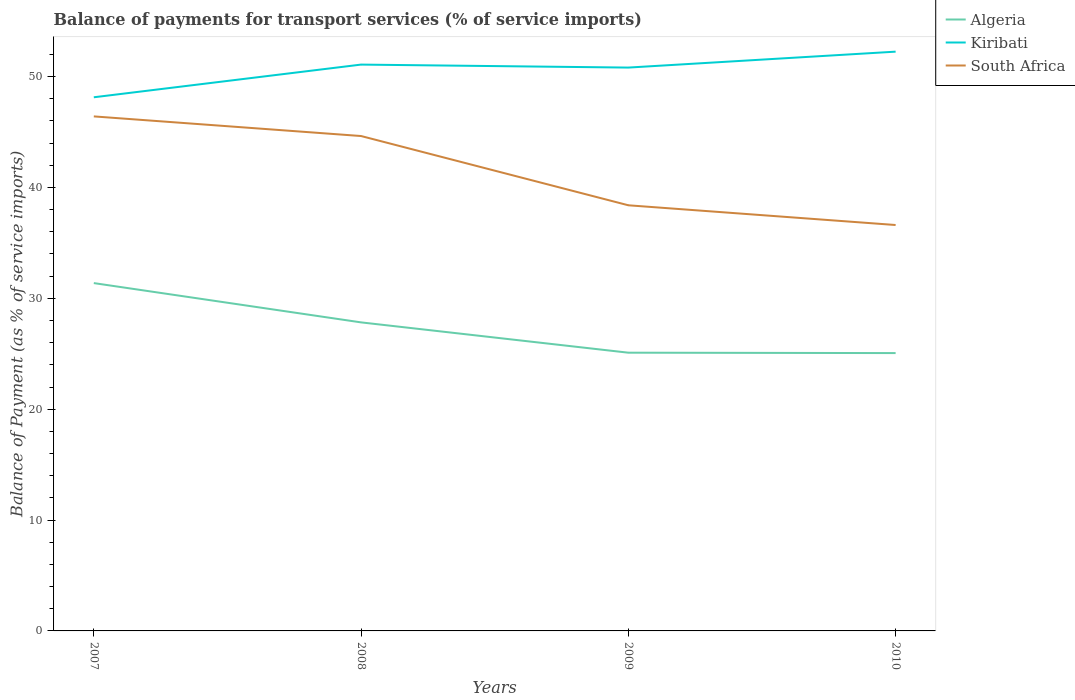Is the number of lines equal to the number of legend labels?
Provide a succinct answer. Yes. Across all years, what is the maximum balance of payments for transport services in Kiribati?
Offer a terse response. 48.13. What is the total balance of payments for transport services in Kiribati in the graph?
Make the answer very short. -2.95. What is the difference between the highest and the second highest balance of payments for transport services in Algeria?
Give a very brief answer. 6.31. Is the balance of payments for transport services in South Africa strictly greater than the balance of payments for transport services in Kiribati over the years?
Your answer should be compact. Yes. How many lines are there?
Your answer should be very brief. 3. How many years are there in the graph?
Make the answer very short. 4. Where does the legend appear in the graph?
Your response must be concise. Top right. What is the title of the graph?
Give a very brief answer. Balance of payments for transport services (% of service imports). What is the label or title of the X-axis?
Ensure brevity in your answer.  Years. What is the label or title of the Y-axis?
Provide a short and direct response. Balance of Payment (as % of service imports). What is the Balance of Payment (as % of service imports) of Algeria in 2007?
Your answer should be very brief. 31.37. What is the Balance of Payment (as % of service imports) of Kiribati in 2007?
Make the answer very short. 48.13. What is the Balance of Payment (as % of service imports) of South Africa in 2007?
Keep it short and to the point. 46.41. What is the Balance of Payment (as % of service imports) in Algeria in 2008?
Make the answer very short. 27.83. What is the Balance of Payment (as % of service imports) of Kiribati in 2008?
Keep it short and to the point. 51.08. What is the Balance of Payment (as % of service imports) in South Africa in 2008?
Give a very brief answer. 44.64. What is the Balance of Payment (as % of service imports) of Algeria in 2009?
Offer a very short reply. 25.1. What is the Balance of Payment (as % of service imports) in Kiribati in 2009?
Make the answer very short. 50.81. What is the Balance of Payment (as % of service imports) in South Africa in 2009?
Provide a succinct answer. 38.39. What is the Balance of Payment (as % of service imports) of Algeria in 2010?
Give a very brief answer. 25.06. What is the Balance of Payment (as % of service imports) in Kiribati in 2010?
Ensure brevity in your answer.  52.25. What is the Balance of Payment (as % of service imports) of South Africa in 2010?
Ensure brevity in your answer.  36.61. Across all years, what is the maximum Balance of Payment (as % of service imports) in Algeria?
Give a very brief answer. 31.37. Across all years, what is the maximum Balance of Payment (as % of service imports) in Kiribati?
Keep it short and to the point. 52.25. Across all years, what is the maximum Balance of Payment (as % of service imports) in South Africa?
Provide a succinct answer. 46.41. Across all years, what is the minimum Balance of Payment (as % of service imports) of Algeria?
Make the answer very short. 25.06. Across all years, what is the minimum Balance of Payment (as % of service imports) in Kiribati?
Your answer should be very brief. 48.13. Across all years, what is the minimum Balance of Payment (as % of service imports) of South Africa?
Offer a terse response. 36.61. What is the total Balance of Payment (as % of service imports) in Algeria in the graph?
Your answer should be compact. 109.36. What is the total Balance of Payment (as % of service imports) of Kiribati in the graph?
Your answer should be compact. 202.28. What is the total Balance of Payment (as % of service imports) of South Africa in the graph?
Keep it short and to the point. 166.05. What is the difference between the Balance of Payment (as % of service imports) of Algeria in 2007 and that in 2008?
Your response must be concise. 3.54. What is the difference between the Balance of Payment (as % of service imports) of Kiribati in 2007 and that in 2008?
Provide a succinct answer. -2.95. What is the difference between the Balance of Payment (as % of service imports) of South Africa in 2007 and that in 2008?
Provide a succinct answer. 1.77. What is the difference between the Balance of Payment (as % of service imports) of Algeria in 2007 and that in 2009?
Offer a very short reply. 6.28. What is the difference between the Balance of Payment (as % of service imports) in Kiribati in 2007 and that in 2009?
Keep it short and to the point. -2.68. What is the difference between the Balance of Payment (as % of service imports) of South Africa in 2007 and that in 2009?
Keep it short and to the point. 8.02. What is the difference between the Balance of Payment (as % of service imports) in Algeria in 2007 and that in 2010?
Ensure brevity in your answer.  6.31. What is the difference between the Balance of Payment (as % of service imports) in Kiribati in 2007 and that in 2010?
Ensure brevity in your answer.  -4.12. What is the difference between the Balance of Payment (as % of service imports) of South Africa in 2007 and that in 2010?
Offer a terse response. 9.8. What is the difference between the Balance of Payment (as % of service imports) of Algeria in 2008 and that in 2009?
Ensure brevity in your answer.  2.73. What is the difference between the Balance of Payment (as % of service imports) in Kiribati in 2008 and that in 2009?
Give a very brief answer. 0.27. What is the difference between the Balance of Payment (as % of service imports) in South Africa in 2008 and that in 2009?
Your answer should be very brief. 6.25. What is the difference between the Balance of Payment (as % of service imports) in Algeria in 2008 and that in 2010?
Your response must be concise. 2.77. What is the difference between the Balance of Payment (as % of service imports) of Kiribati in 2008 and that in 2010?
Your answer should be very brief. -1.17. What is the difference between the Balance of Payment (as % of service imports) in South Africa in 2008 and that in 2010?
Offer a very short reply. 8.03. What is the difference between the Balance of Payment (as % of service imports) in Algeria in 2009 and that in 2010?
Ensure brevity in your answer.  0.04. What is the difference between the Balance of Payment (as % of service imports) in Kiribati in 2009 and that in 2010?
Make the answer very short. -1.44. What is the difference between the Balance of Payment (as % of service imports) in South Africa in 2009 and that in 2010?
Your answer should be very brief. 1.78. What is the difference between the Balance of Payment (as % of service imports) in Algeria in 2007 and the Balance of Payment (as % of service imports) in Kiribati in 2008?
Offer a very short reply. -19.71. What is the difference between the Balance of Payment (as % of service imports) in Algeria in 2007 and the Balance of Payment (as % of service imports) in South Africa in 2008?
Provide a short and direct response. -13.26. What is the difference between the Balance of Payment (as % of service imports) of Kiribati in 2007 and the Balance of Payment (as % of service imports) of South Africa in 2008?
Your answer should be very brief. 3.5. What is the difference between the Balance of Payment (as % of service imports) of Algeria in 2007 and the Balance of Payment (as % of service imports) of Kiribati in 2009?
Offer a very short reply. -19.44. What is the difference between the Balance of Payment (as % of service imports) of Algeria in 2007 and the Balance of Payment (as % of service imports) of South Africa in 2009?
Your answer should be compact. -7.02. What is the difference between the Balance of Payment (as % of service imports) in Kiribati in 2007 and the Balance of Payment (as % of service imports) in South Africa in 2009?
Keep it short and to the point. 9.74. What is the difference between the Balance of Payment (as % of service imports) of Algeria in 2007 and the Balance of Payment (as % of service imports) of Kiribati in 2010?
Offer a terse response. -20.88. What is the difference between the Balance of Payment (as % of service imports) in Algeria in 2007 and the Balance of Payment (as % of service imports) in South Africa in 2010?
Provide a succinct answer. -5.24. What is the difference between the Balance of Payment (as % of service imports) in Kiribati in 2007 and the Balance of Payment (as % of service imports) in South Africa in 2010?
Keep it short and to the point. 11.52. What is the difference between the Balance of Payment (as % of service imports) of Algeria in 2008 and the Balance of Payment (as % of service imports) of Kiribati in 2009?
Your answer should be very brief. -22.98. What is the difference between the Balance of Payment (as % of service imports) of Algeria in 2008 and the Balance of Payment (as % of service imports) of South Africa in 2009?
Your answer should be very brief. -10.56. What is the difference between the Balance of Payment (as % of service imports) in Kiribati in 2008 and the Balance of Payment (as % of service imports) in South Africa in 2009?
Your answer should be compact. 12.69. What is the difference between the Balance of Payment (as % of service imports) of Algeria in 2008 and the Balance of Payment (as % of service imports) of Kiribati in 2010?
Your answer should be compact. -24.42. What is the difference between the Balance of Payment (as % of service imports) of Algeria in 2008 and the Balance of Payment (as % of service imports) of South Africa in 2010?
Your answer should be compact. -8.78. What is the difference between the Balance of Payment (as % of service imports) in Kiribati in 2008 and the Balance of Payment (as % of service imports) in South Africa in 2010?
Give a very brief answer. 14.47. What is the difference between the Balance of Payment (as % of service imports) of Algeria in 2009 and the Balance of Payment (as % of service imports) of Kiribati in 2010?
Provide a short and direct response. -27.15. What is the difference between the Balance of Payment (as % of service imports) in Algeria in 2009 and the Balance of Payment (as % of service imports) in South Africa in 2010?
Provide a succinct answer. -11.52. What is the difference between the Balance of Payment (as % of service imports) in Kiribati in 2009 and the Balance of Payment (as % of service imports) in South Africa in 2010?
Make the answer very short. 14.2. What is the average Balance of Payment (as % of service imports) in Algeria per year?
Give a very brief answer. 27.34. What is the average Balance of Payment (as % of service imports) of Kiribati per year?
Provide a succinct answer. 50.57. What is the average Balance of Payment (as % of service imports) of South Africa per year?
Provide a succinct answer. 41.51. In the year 2007, what is the difference between the Balance of Payment (as % of service imports) in Algeria and Balance of Payment (as % of service imports) in Kiribati?
Provide a short and direct response. -16.76. In the year 2007, what is the difference between the Balance of Payment (as % of service imports) of Algeria and Balance of Payment (as % of service imports) of South Africa?
Offer a very short reply. -15.04. In the year 2007, what is the difference between the Balance of Payment (as % of service imports) of Kiribati and Balance of Payment (as % of service imports) of South Africa?
Offer a very short reply. 1.72. In the year 2008, what is the difference between the Balance of Payment (as % of service imports) in Algeria and Balance of Payment (as % of service imports) in Kiribati?
Give a very brief answer. -23.25. In the year 2008, what is the difference between the Balance of Payment (as % of service imports) of Algeria and Balance of Payment (as % of service imports) of South Africa?
Offer a very short reply. -16.81. In the year 2008, what is the difference between the Balance of Payment (as % of service imports) of Kiribati and Balance of Payment (as % of service imports) of South Africa?
Your response must be concise. 6.44. In the year 2009, what is the difference between the Balance of Payment (as % of service imports) in Algeria and Balance of Payment (as % of service imports) in Kiribati?
Your answer should be compact. -25.72. In the year 2009, what is the difference between the Balance of Payment (as % of service imports) in Algeria and Balance of Payment (as % of service imports) in South Africa?
Give a very brief answer. -13.3. In the year 2009, what is the difference between the Balance of Payment (as % of service imports) in Kiribati and Balance of Payment (as % of service imports) in South Africa?
Ensure brevity in your answer.  12.42. In the year 2010, what is the difference between the Balance of Payment (as % of service imports) in Algeria and Balance of Payment (as % of service imports) in Kiribati?
Ensure brevity in your answer.  -27.19. In the year 2010, what is the difference between the Balance of Payment (as % of service imports) in Algeria and Balance of Payment (as % of service imports) in South Africa?
Your answer should be compact. -11.55. In the year 2010, what is the difference between the Balance of Payment (as % of service imports) of Kiribati and Balance of Payment (as % of service imports) of South Africa?
Provide a succinct answer. 15.64. What is the ratio of the Balance of Payment (as % of service imports) of Algeria in 2007 to that in 2008?
Keep it short and to the point. 1.13. What is the ratio of the Balance of Payment (as % of service imports) of Kiribati in 2007 to that in 2008?
Provide a succinct answer. 0.94. What is the ratio of the Balance of Payment (as % of service imports) in South Africa in 2007 to that in 2008?
Your answer should be compact. 1.04. What is the ratio of the Balance of Payment (as % of service imports) in Algeria in 2007 to that in 2009?
Provide a succinct answer. 1.25. What is the ratio of the Balance of Payment (as % of service imports) of Kiribati in 2007 to that in 2009?
Make the answer very short. 0.95. What is the ratio of the Balance of Payment (as % of service imports) of South Africa in 2007 to that in 2009?
Offer a very short reply. 1.21. What is the ratio of the Balance of Payment (as % of service imports) in Algeria in 2007 to that in 2010?
Keep it short and to the point. 1.25. What is the ratio of the Balance of Payment (as % of service imports) in Kiribati in 2007 to that in 2010?
Make the answer very short. 0.92. What is the ratio of the Balance of Payment (as % of service imports) of South Africa in 2007 to that in 2010?
Your answer should be very brief. 1.27. What is the ratio of the Balance of Payment (as % of service imports) of Algeria in 2008 to that in 2009?
Give a very brief answer. 1.11. What is the ratio of the Balance of Payment (as % of service imports) in South Africa in 2008 to that in 2009?
Provide a succinct answer. 1.16. What is the ratio of the Balance of Payment (as % of service imports) of Algeria in 2008 to that in 2010?
Make the answer very short. 1.11. What is the ratio of the Balance of Payment (as % of service imports) of Kiribati in 2008 to that in 2010?
Your response must be concise. 0.98. What is the ratio of the Balance of Payment (as % of service imports) in South Africa in 2008 to that in 2010?
Offer a terse response. 1.22. What is the ratio of the Balance of Payment (as % of service imports) in Kiribati in 2009 to that in 2010?
Offer a terse response. 0.97. What is the ratio of the Balance of Payment (as % of service imports) in South Africa in 2009 to that in 2010?
Offer a very short reply. 1.05. What is the difference between the highest and the second highest Balance of Payment (as % of service imports) of Algeria?
Offer a very short reply. 3.54. What is the difference between the highest and the second highest Balance of Payment (as % of service imports) in Kiribati?
Your answer should be very brief. 1.17. What is the difference between the highest and the second highest Balance of Payment (as % of service imports) of South Africa?
Provide a succinct answer. 1.77. What is the difference between the highest and the lowest Balance of Payment (as % of service imports) of Algeria?
Give a very brief answer. 6.31. What is the difference between the highest and the lowest Balance of Payment (as % of service imports) in Kiribati?
Make the answer very short. 4.12. What is the difference between the highest and the lowest Balance of Payment (as % of service imports) in South Africa?
Ensure brevity in your answer.  9.8. 